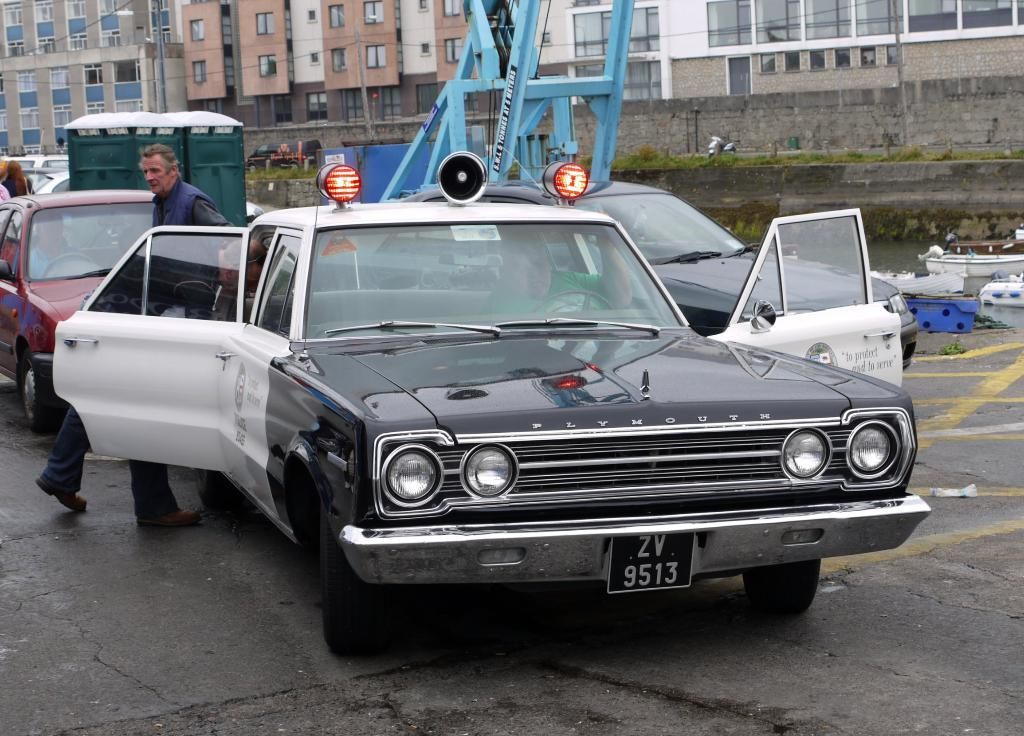What types of vehicles can be seen in the image? There are motor vehicles in the image. What are the people in the image doing? There are persons standing on the road in the image. What large machinery is present in the image? There is a crane in the image. What type of structures can be seen in the image? There are buildings in the image. What architectural elements are visible in the image? There are walls in the image. What type of vegetation is present in the image? There are plants in the image. What natural element is visible in the image? There is water visible in the image. What man-made infrastructure can be seen in the image? There are electric cables in the image. What type of home does the committee meet in during the image? There is no mention of a committee or a home in the image. The image features motor vehicles, persons standing on the road, a crane, buildings, walls, plants, water, and electric cables. 